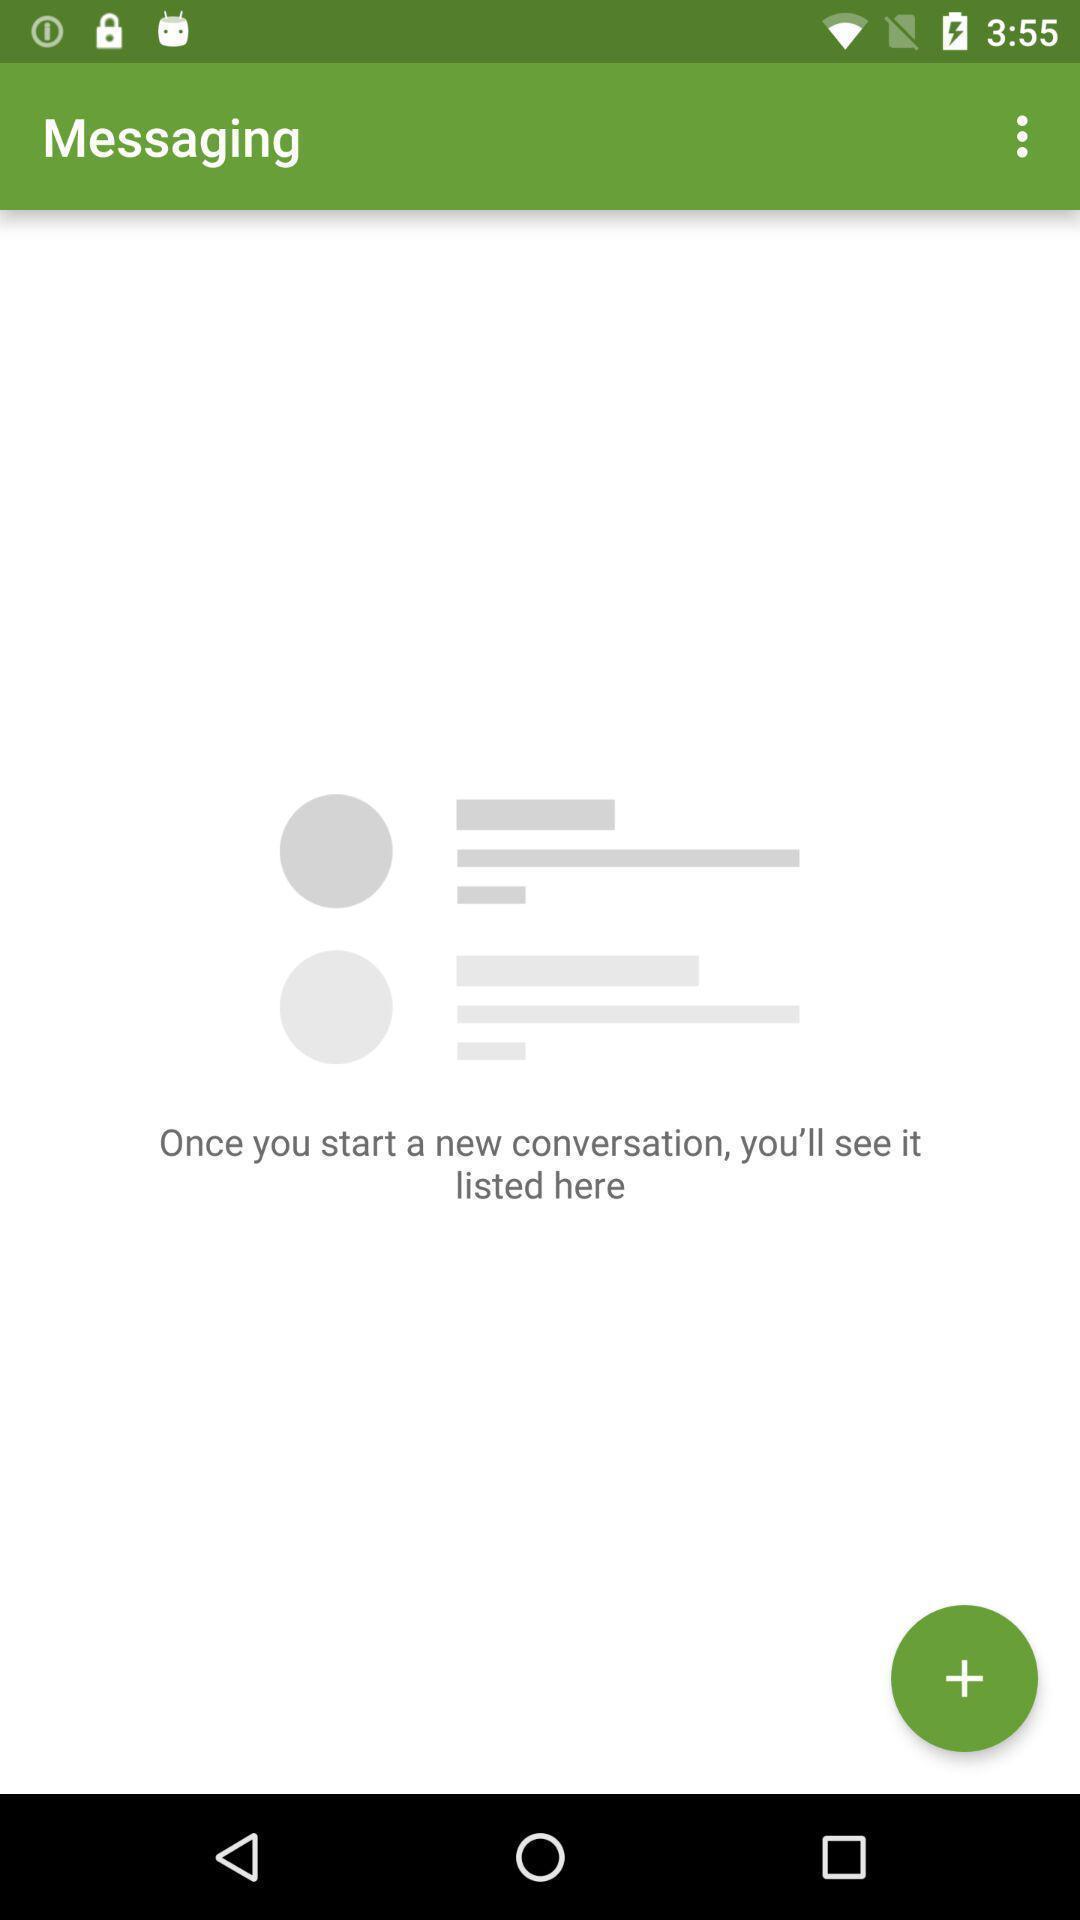What can you discern from this picture? Screen shows messaging page. 